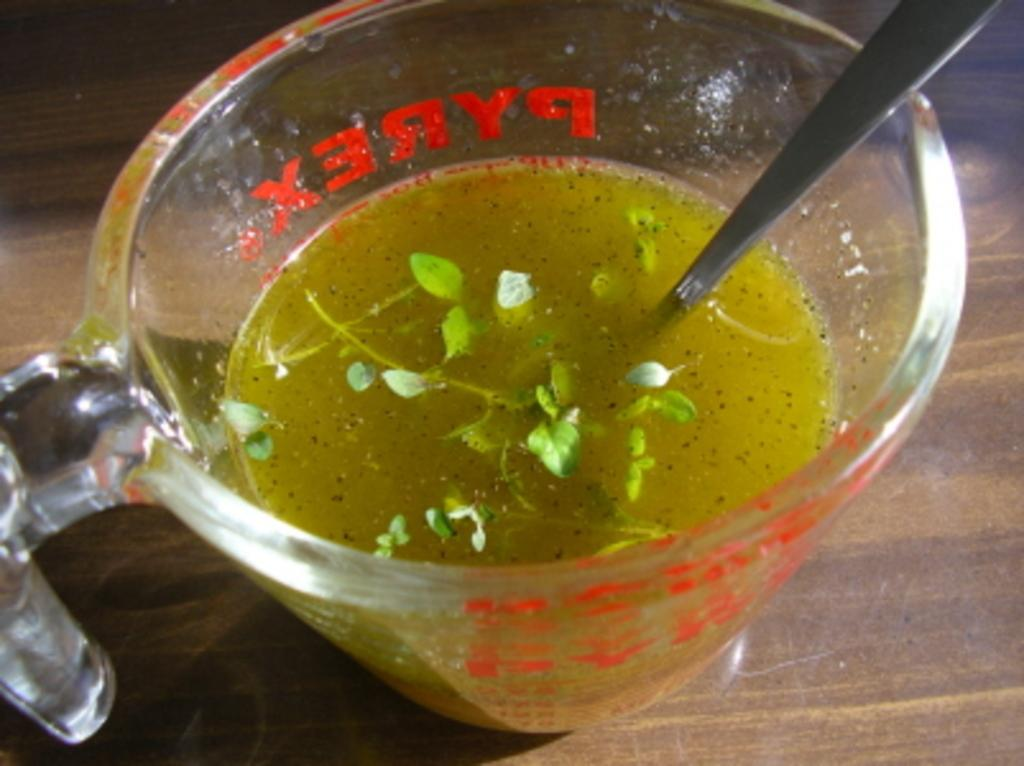What is in the image that can hold a drink? There is a cup in the image that can hold a drink. What is inside the cup? There is a drink in the cup. What is unique about the drink in the cup? The drink has leaves in it. What utensil is present in the drink? There is a spoon in the drink. On what surface is the cup placed? The cup is placed on a brown-colored table. What type of haircut does the cactus have in the image? There is no cactus present in the image, so it is not possible to answer that question. 